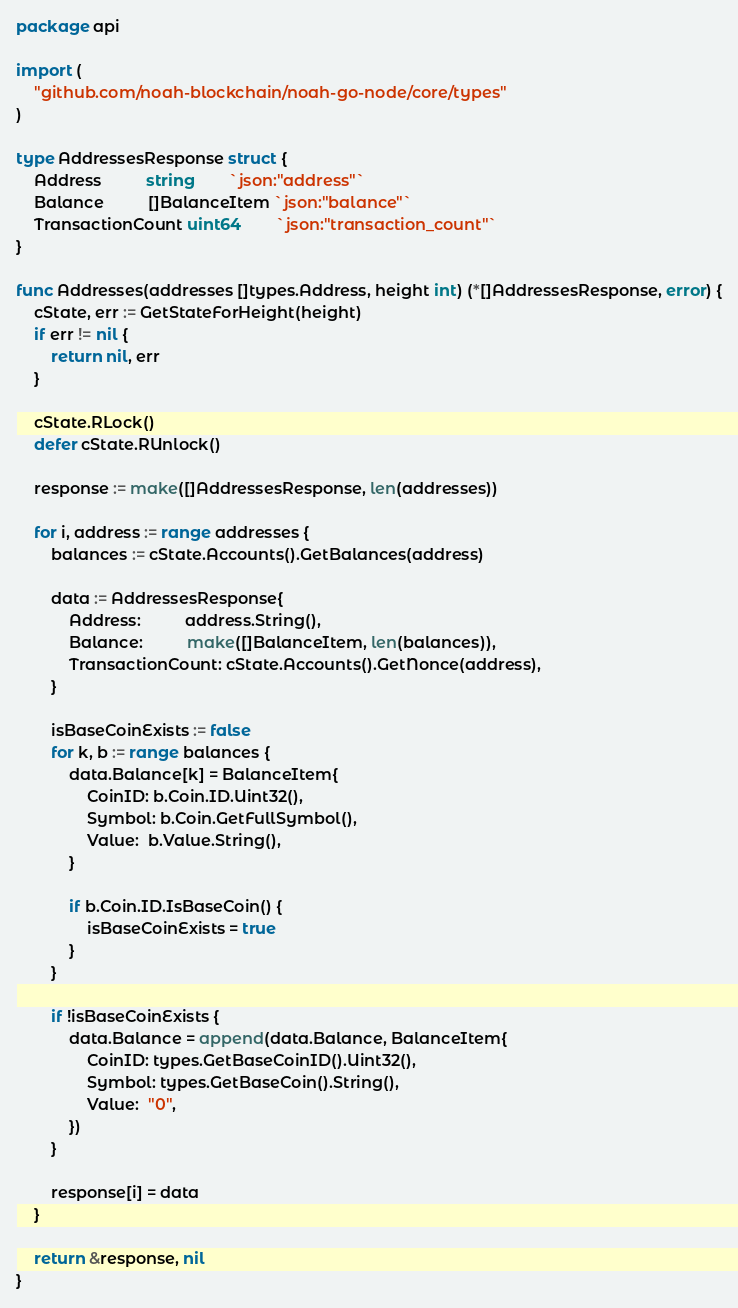Convert code to text. <code><loc_0><loc_0><loc_500><loc_500><_Go_>package api

import (
	"github.com/noah-blockchain/noah-go-node/core/types"
)

type AddressesResponse struct {
	Address          string        `json:"address"`
	Balance          []BalanceItem `json:"balance"`
	TransactionCount uint64        `json:"transaction_count"`
}

func Addresses(addresses []types.Address, height int) (*[]AddressesResponse, error) {
	cState, err := GetStateForHeight(height)
	if err != nil {
		return nil, err
	}

	cState.RLock()
	defer cState.RUnlock()

	response := make([]AddressesResponse, len(addresses))

	for i, address := range addresses {
		balances := cState.Accounts().GetBalances(address)

		data := AddressesResponse{
			Address:          address.String(),
			Balance:          make([]BalanceItem, len(balances)),
			TransactionCount: cState.Accounts().GetNonce(address),
		}

		isBaseCoinExists := false
		for k, b := range balances {
			data.Balance[k] = BalanceItem{
				CoinID: b.Coin.ID.Uint32(),
				Symbol: b.Coin.GetFullSymbol(),
				Value:  b.Value.String(),
			}

			if b.Coin.ID.IsBaseCoin() {
				isBaseCoinExists = true
			}
		}

		if !isBaseCoinExists {
			data.Balance = append(data.Balance, BalanceItem{
				CoinID: types.GetBaseCoinID().Uint32(),
				Symbol: types.GetBaseCoin().String(),
				Value:  "0",
			})
		}

		response[i] = data
	}

	return &response, nil
}
</code> 